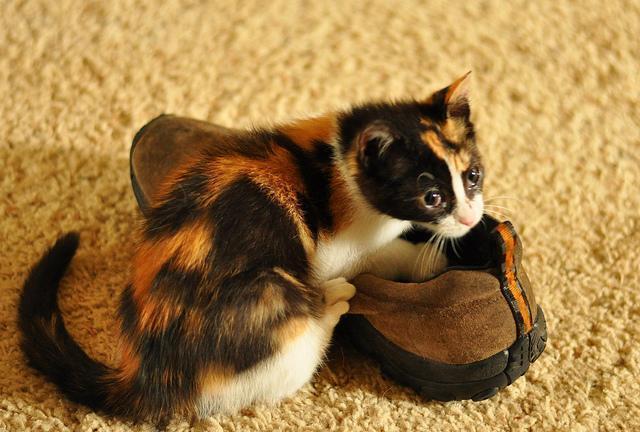How many cats are there?
Give a very brief answer. 1. How many boys are present?
Give a very brief answer. 0. 